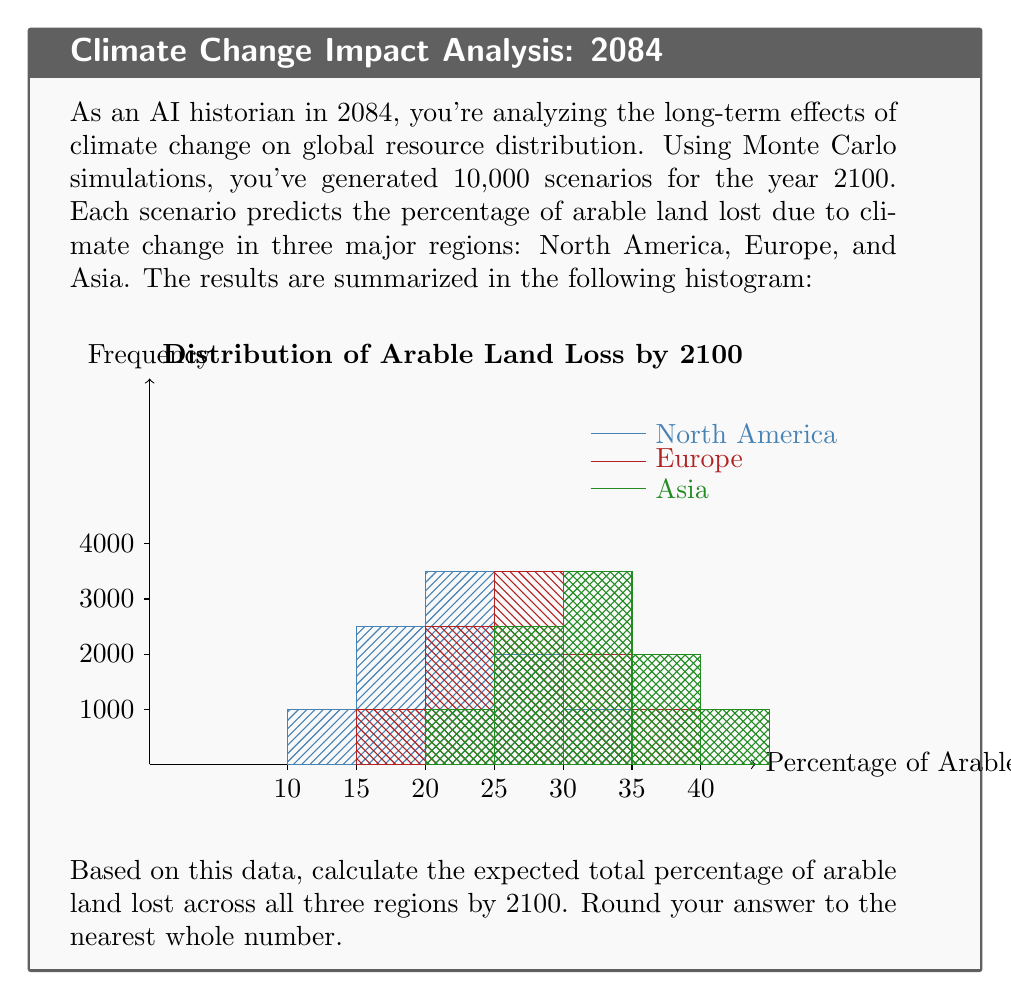Provide a solution to this math problem. To solve this problem, we need to follow these steps:

1) First, let's calculate the expected percentage of arable land lost for each region:

   For each region, we'll use the formula:
   $$ E(X) = \sum_{i=1}^{n} x_i \cdot p(x_i) $$
   where $x_i$ are the possible outcomes and $p(x_i)$ are their respective probabilities.

2) For North America:
   $$ E(NA) = 10 \cdot 0.1 + 15 \cdot 0.25 + 20 \cdot 0.35 + 25 \cdot 0.2 + 30 \cdot 0.1 = 20\% $$

3) For Europe:
   $$ E(EU) = 15 \cdot 0.1 + 20 \cdot 0.25 + 25 \cdot 0.35 + 30 \cdot 0.2 + 35 \cdot 0.1 = 25\% $$

4) For Asia:
   $$ E(AS) = 20 \cdot 0.1 + 25 \cdot 0.25 + 30 \cdot 0.35 + 35 \cdot 0.2 + 40 \cdot 0.1 = 30\% $$

5) The total expected percentage of arable land lost is the sum of these three expectations:
   $$ E(Total) = E(NA) + E(EU) + E(AS) = 20\% + 25\% + 30\% = 75\% $$

6) Rounding to the nearest whole number: 75%

Therefore, based on the Monte Carlo simulations, the expected total percentage of arable land lost across North America, Europe, and Asia by 2100 is 75%.
Answer: 75% 